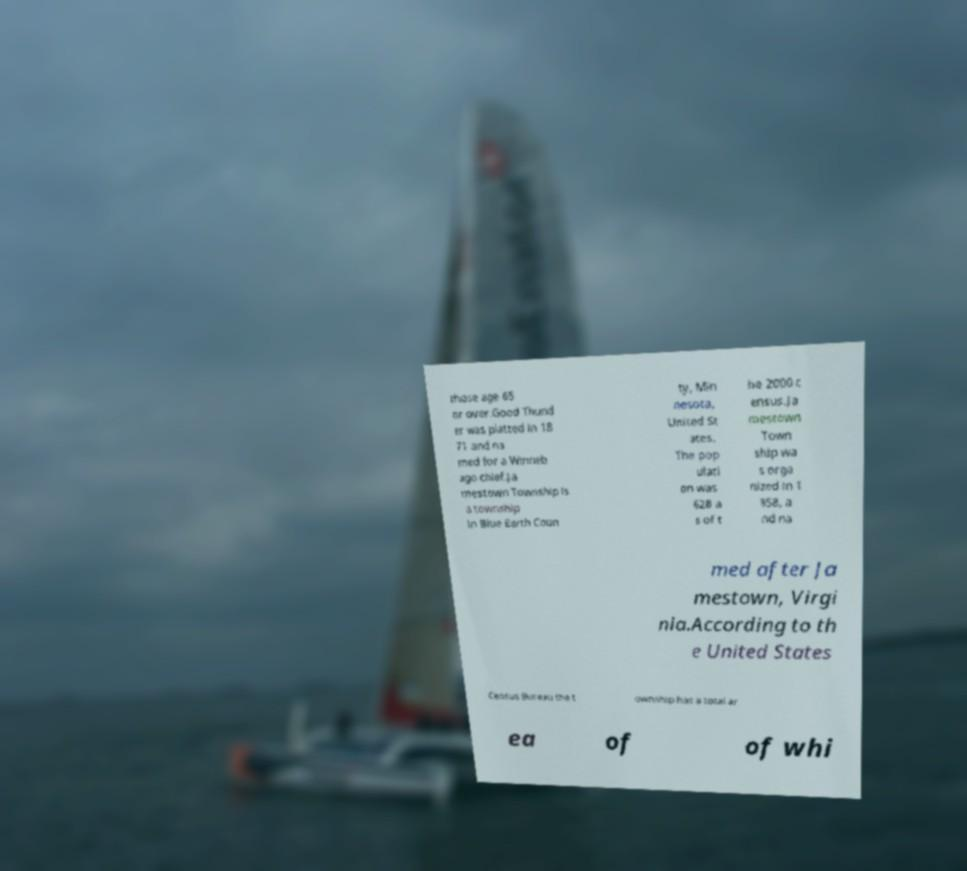What messages or text are displayed in this image? I need them in a readable, typed format. those age 65 or over.Good Thund er was platted in 18 71 and na med for a Winneb ago chief.Ja mestown Township is a township in Blue Earth Coun ty, Min nesota, United St ates. The pop ulati on was 628 a s of t he 2000 c ensus.Ja mestown Town ship wa s orga nized in 1 858, a nd na med after Ja mestown, Virgi nia.According to th e United States Census Bureau the t ownship has a total ar ea of of whi 